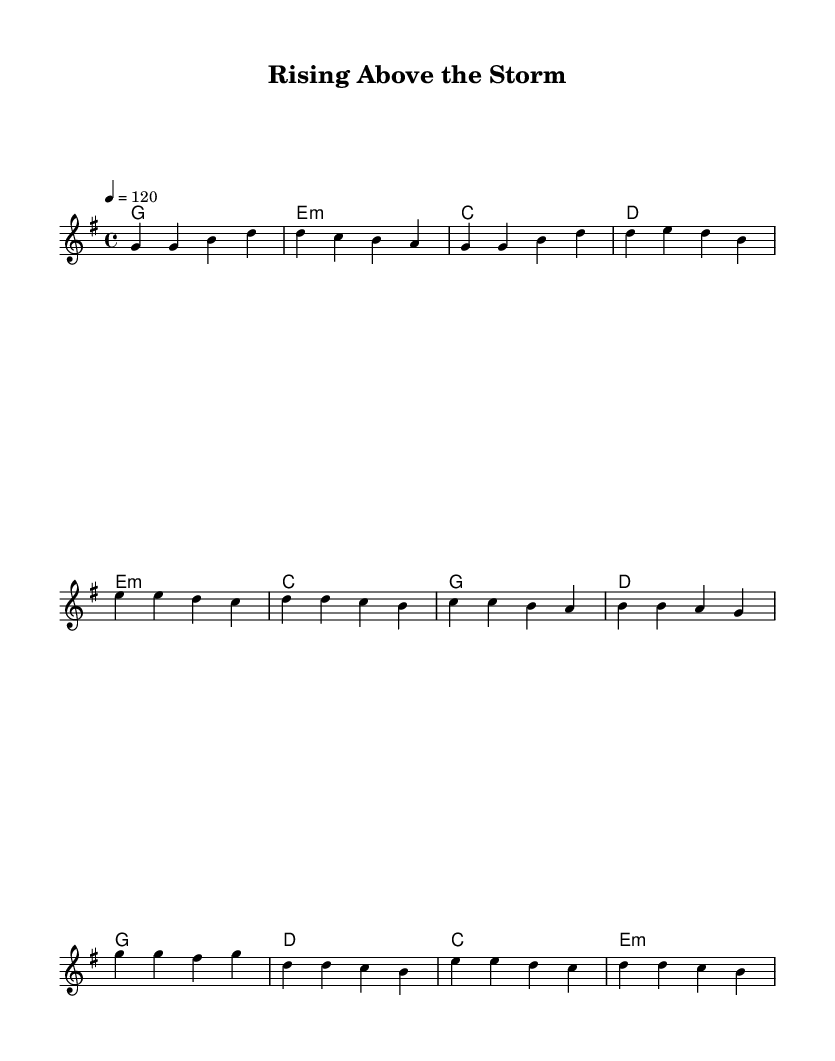What is the key signature of this music? The key signature is G major, which has one sharp (F#). You can determine this by looking at the `\key g \major` declaration in the global settings of the score.
Answer: G major What is the time signature of this music? The time signature is 4/4, which indicates four beats per measure. This information is found in the `\time 4/4` declaration in the global settings of the score.
Answer: 4/4 What is the tempo marking for this piece? The tempo marking is "4 = 120," which means to play at a speed of 120 beats per minute. This is specified in the global section of the score under `\tempo 4 = 120`.
Answer: 120 How many measures are in the chorus? The chorus consists of four measures, which can be counted from the melody defined in `melodyChorus` as it contains four distinct bars of music.
Answer: 4 What lyrics accompany the pre-chorus? The lyrics for the pre-chorus are: "Though the world may shake, our spirits rise / Together we'll reach for brighter skies." You can find these lyrics in the `preChorusWords` definition in the score.
Answer: "Though the world may shake, our spirits rise / Together we'll reach for brighter skies." Which chord is played during the first measure of the verse? The first measure of the verse has the chord G major. You can see this in the `\harmonies` section where the first chord listed is `g1`, indicating it spans the entire measure.
Answer: G major 